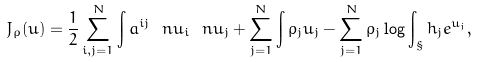<formula> <loc_0><loc_0><loc_500><loc_500>J _ { \rho } ( u ) = \frac { 1 } { 2 } \sum _ { i , j = 1 } ^ { N } \int a ^ { i j } \ n u _ { i } \ n u _ { j } + \sum _ { j = 1 } ^ { N } \int \rho _ { j } u _ { j } - \sum _ { j = 1 } ^ { N } \rho _ { j } \log \int _ { \S } h _ { j } e ^ { u _ { j } } ,</formula> 